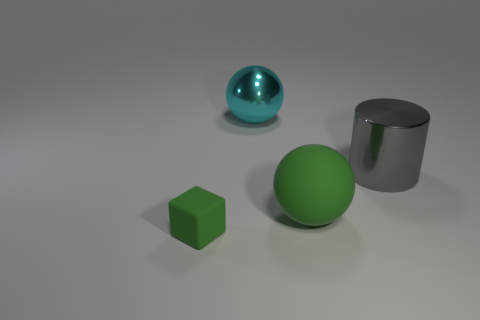Is the size of the sphere behind the cylinder the same as the green object on the left side of the rubber sphere?
Your answer should be very brief. No. There is a sphere that is behind the large gray cylinder; what is its size?
Give a very brief answer. Large. There is a object that is on the right side of the sphere in front of the large cylinder; what is its size?
Ensure brevity in your answer.  Large. There is a cylinder that is the same size as the cyan sphere; what is its material?
Your answer should be compact. Metal. There is a metallic sphere; are there any large spheres behind it?
Give a very brief answer. No. Are there an equal number of green things behind the gray metal object and large rubber things?
Offer a very short reply. No. There is another metal object that is the same size as the cyan shiny thing; what is its shape?
Make the answer very short. Cylinder. What material is the large green ball?
Provide a short and direct response. Rubber. What is the color of the big thing that is to the right of the cyan thing and to the left of the metallic cylinder?
Your answer should be very brief. Green. Is the number of big green matte objects that are to the left of the green rubber sphere the same as the number of spheres in front of the small green rubber block?
Your answer should be compact. Yes. 